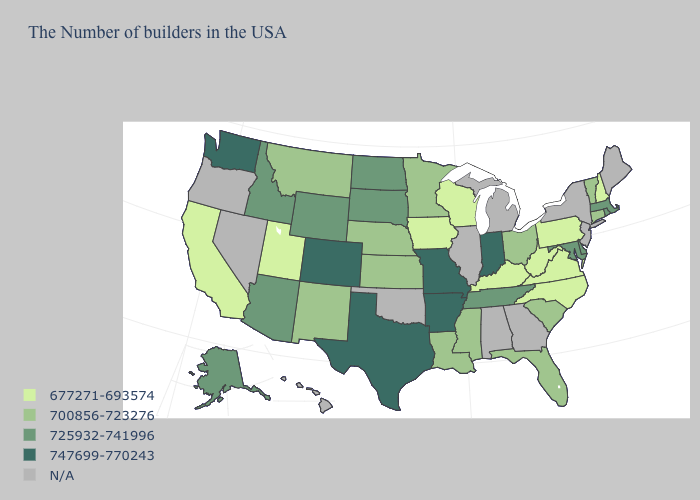Name the states that have a value in the range 700856-723276?
Keep it brief. Vermont, Connecticut, South Carolina, Ohio, Florida, Mississippi, Louisiana, Minnesota, Kansas, Nebraska, New Mexico, Montana. Name the states that have a value in the range 677271-693574?
Short answer required. New Hampshire, Pennsylvania, Virginia, North Carolina, West Virginia, Kentucky, Wisconsin, Iowa, Utah, California. Does the map have missing data?
Be succinct. Yes. Which states hav the highest value in the West?
Be succinct. Colorado, Washington. Name the states that have a value in the range 747699-770243?
Short answer required. Indiana, Missouri, Arkansas, Texas, Colorado, Washington. What is the highest value in the MidWest ?
Quick response, please. 747699-770243. What is the value of New Jersey?
Concise answer only. N/A. Name the states that have a value in the range 725932-741996?
Quick response, please. Massachusetts, Rhode Island, Delaware, Maryland, Tennessee, South Dakota, North Dakota, Wyoming, Arizona, Idaho, Alaska. Which states have the lowest value in the South?
Write a very short answer. Virginia, North Carolina, West Virginia, Kentucky. What is the value of Maine?
Concise answer only. N/A. Which states have the lowest value in the South?
Be succinct. Virginia, North Carolina, West Virginia, Kentucky. Name the states that have a value in the range N/A?
Be succinct. Maine, New York, New Jersey, Georgia, Michigan, Alabama, Illinois, Oklahoma, Nevada, Oregon, Hawaii. Name the states that have a value in the range 677271-693574?
Short answer required. New Hampshire, Pennsylvania, Virginia, North Carolina, West Virginia, Kentucky, Wisconsin, Iowa, Utah, California. What is the highest value in the USA?
Short answer required. 747699-770243. 